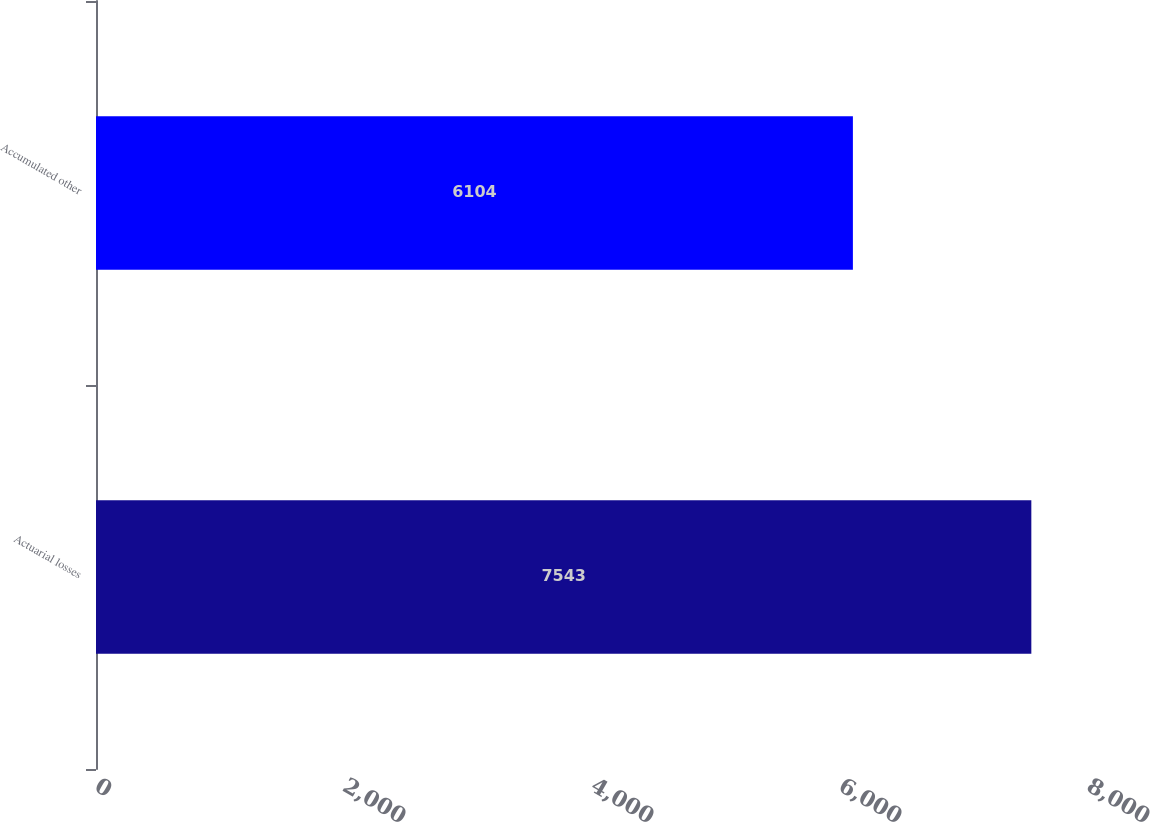Convert chart to OTSL. <chart><loc_0><loc_0><loc_500><loc_500><bar_chart><fcel>Actuarial losses<fcel>Accumulated other<nl><fcel>7543<fcel>6104<nl></chart> 